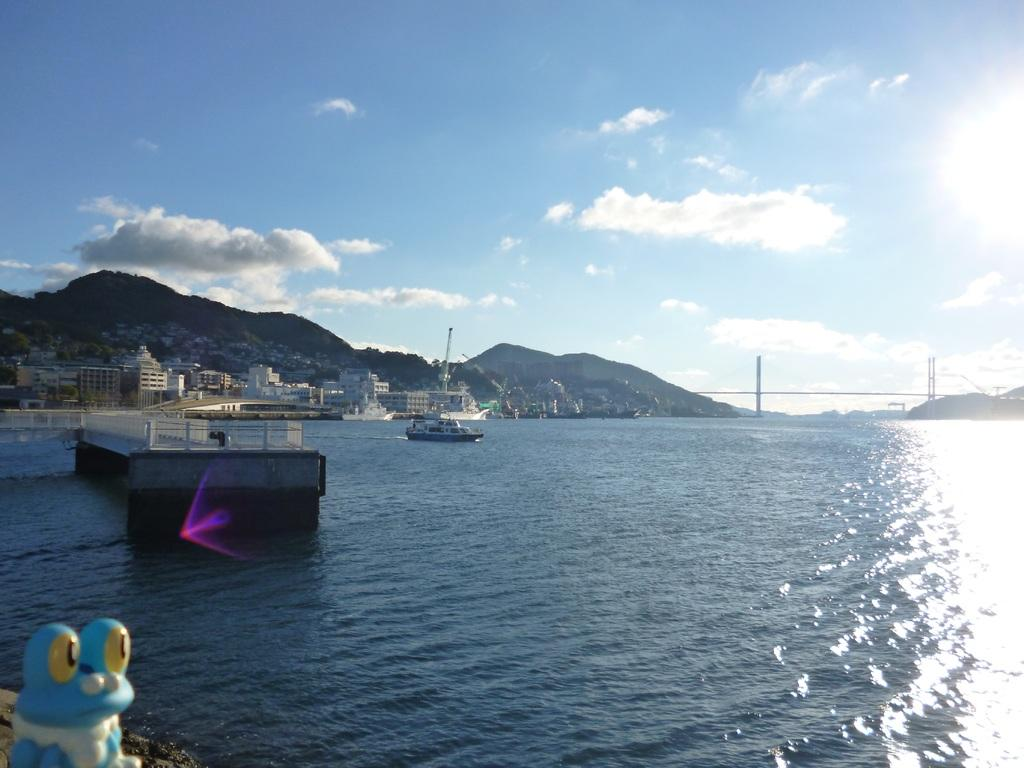What is the main subject of the image? The main subject of the image is a boat. Where is the boat located? The boat is on the water. What can be seen in the background of the image? Buildings, mountains, and a bridge are visible in the background. What is visible at the top of the image? The sky is visible at the top of the image. What object is located in the bottom left corner of the image? There is a toy in the bottom left corner of the image. Is the ground covered in snow in the image? There is no indication of snow or winter conditions in the image. What type of class is being held in the boat in the image? There is no class or educational activity taking place in the boat in the image. 